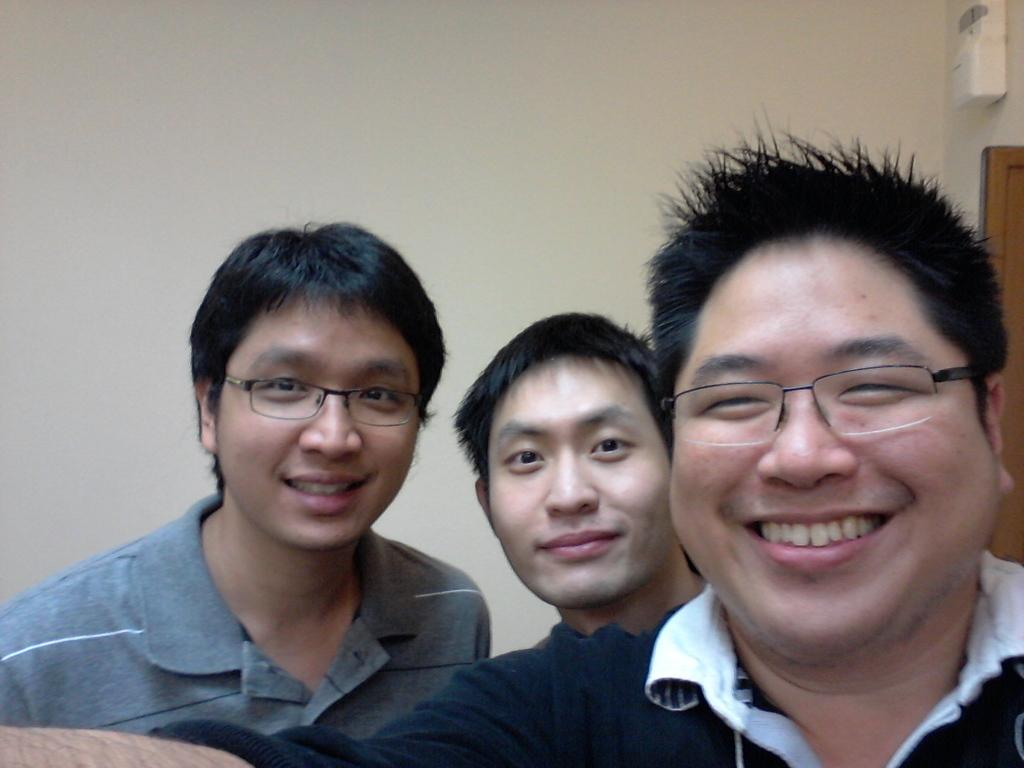How many people are in the image? There are three men in the image. What expressions do the men have? All three men are smiling. What accessory do two of the men have in common? Two of the men are wearing spectacles. What can be seen in the background of the image? There is a wall in the background of the image. What type of wool is being used to soothe the men's throats in the image? There is no wool or indication of throat soothing in the image; the men are simply smiling. What tin object can be seen in the hands of the men in the image? There is no tin object present in the image. 